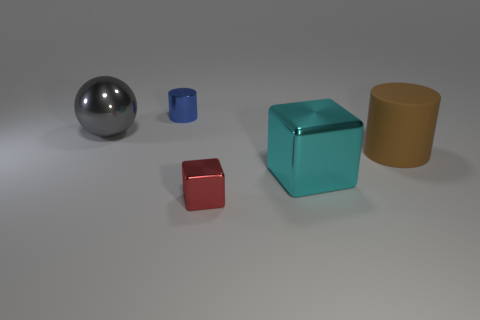What color is the metal thing behind the big thing that is to the left of the tiny blue shiny thing?
Give a very brief answer. Blue. What material is the other object that is the same shape as the tiny blue metallic object?
Ensure brevity in your answer.  Rubber. How many metallic objects are large balls or cyan cubes?
Provide a short and direct response. 2. Are the cylinder that is in front of the gray metallic thing and the big object left of the small cylinder made of the same material?
Offer a terse response. No. Are there any blue shiny cylinders?
Make the answer very short. Yes. Is the shape of the small shiny thing behind the tiny red metallic block the same as the tiny shiny thing that is in front of the big gray metallic ball?
Provide a succinct answer. No. Are there any big things made of the same material as the ball?
Your answer should be very brief. Yes. Is the material of the cylinder in front of the metal sphere the same as the blue cylinder?
Give a very brief answer. No. Are there more cyan metal things to the right of the large brown matte cylinder than brown cylinders in front of the large metallic sphere?
Your response must be concise. No. The other metal object that is the same size as the blue thing is what color?
Keep it short and to the point. Red. 